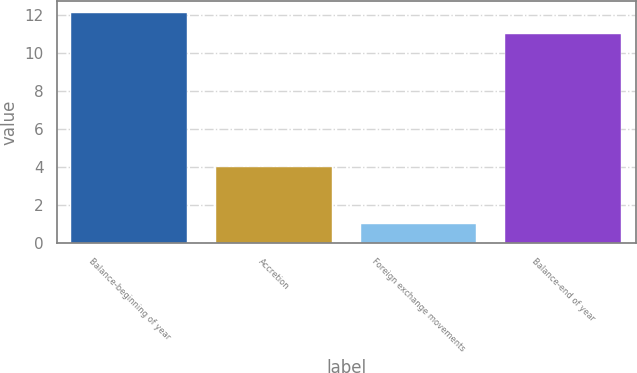<chart> <loc_0><loc_0><loc_500><loc_500><bar_chart><fcel>Balance-beginning of year<fcel>Accretion<fcel>Foreign exchange movements<fcel>Balance-end of year<nl><fcel>12.1<fcel>4<fcel>1<fcel>11<nl></chart> 